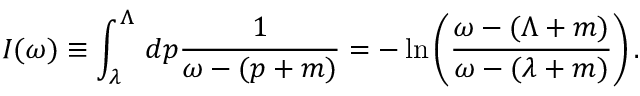Convert formula to latex. <formula><loc_0><loc_0><loc_500><loc_500>I ( \omega ) \equiv \int _ { \lambda } ^ { \Lambda } \, d p \frac { 1 } { \omega - ( p + m ) } = - \, \ln \left ( \frac { \omega - ( \Lambda + m ) } { \omega - ( \lambda + m ) } \right ) .</formula> 